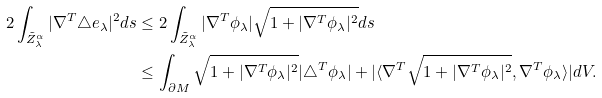<formula> <loc_0><loc_0><loc_500><loc_500>2 \int _ { \tilde { Z } _ { \lambda } ^ { \alpha } } | \nabla ^ { T } \triangle e _ { \lambda } | ^ { 2 } d s & \leq 2 \int _ { \tilde { Z } _ { \lambda } ^ { \alpha } } | \nabla ^ { T } \phi _ { \lambda } | \sqrt { 1 + | \nabla ^ { T } \phi _ { \lambda } | ^ { 2 } } d s \\ & \leq \int _ { \partial M } \sqrt { 1 + | \nabla ^ { T } \phi _ { \lambda } | ^ { 2 } } | \triangle ^ { T } \phi _ { \lambda } | + | \langle \nabla ^ { T } \sqrt { 1 + | \nabla ^ { T } \phi _ { \lambda } | ^ { 2 } } , \nabla ^ { T } \phi _ { \lambda } \rangle | d V .</formula> 